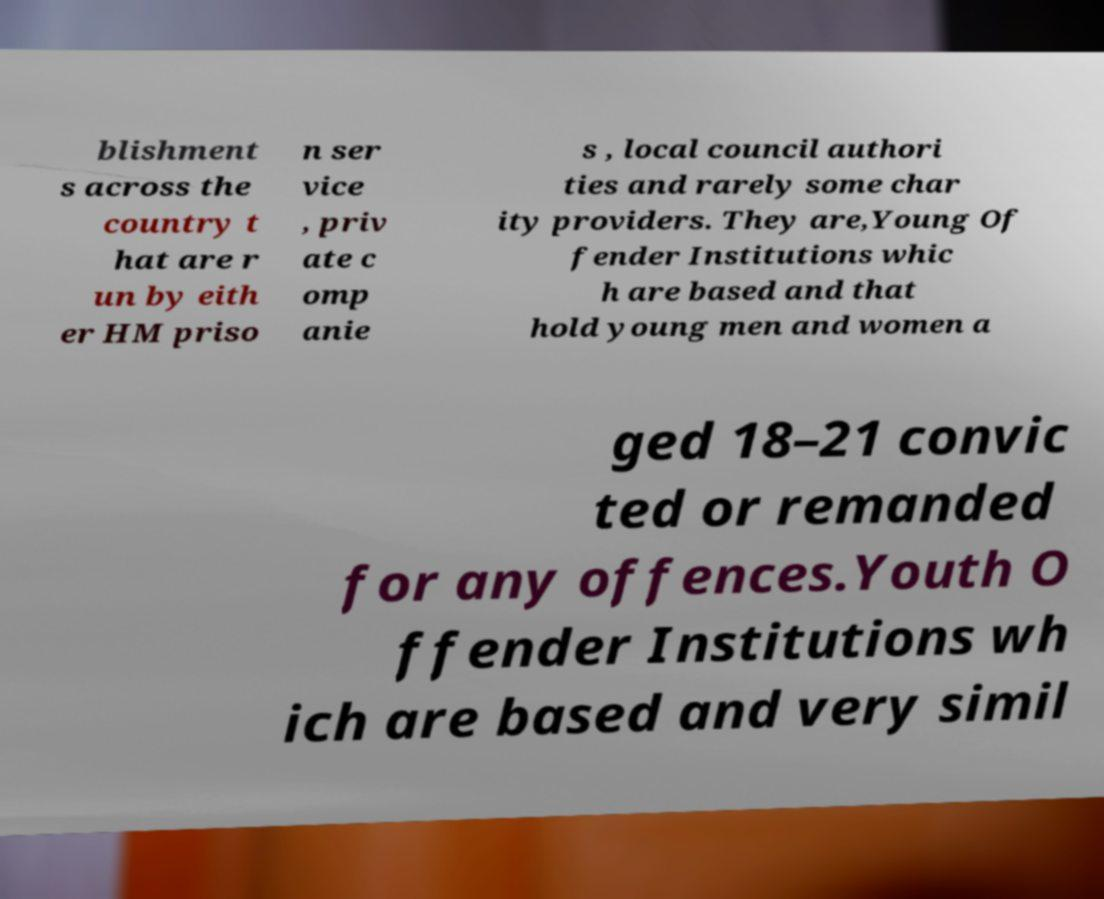Can you read and provide the text displayed in the image?This photo seems to have some interesting text. Can you extract and type it out for me? blishment s across the country t hat are r un by eith er HM priso n ser vice , priv ate c omp anie s , local council authori ties and rarely some char ity providers. They are,Young Of fender Institutions whic h are based and that hold young men and women a ged 18–21 convic ted or remanded for any offences.Youth O ffender Institutions wh ich are based and very simil 